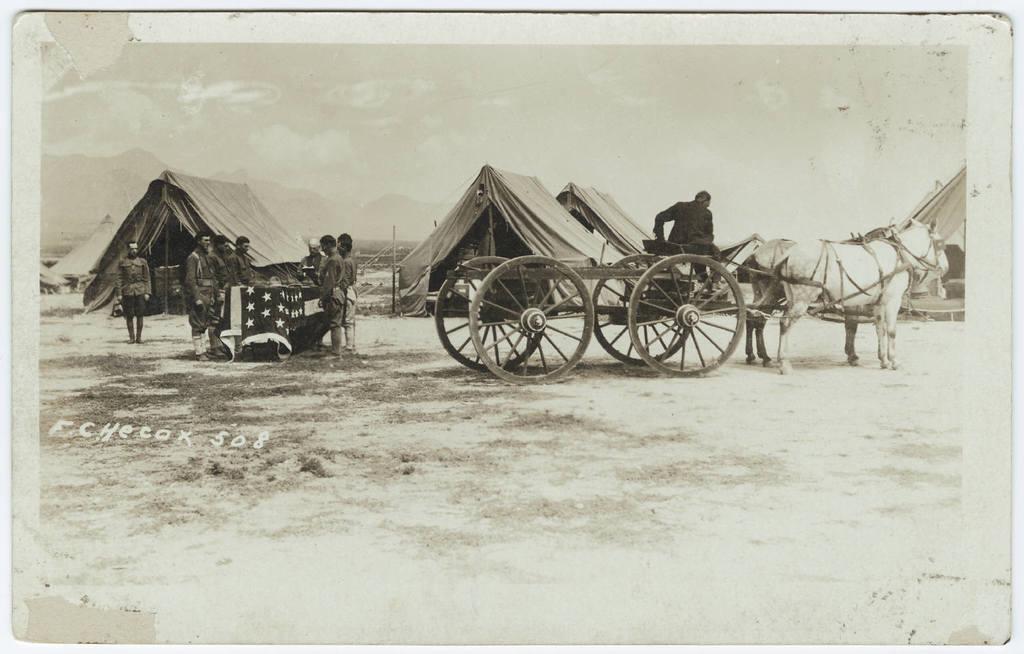How would you summarize this image in a sentence or two? It is an old black and white image. In the left side there are people standing. In the right side it is a horse cart. In the middle there are tents. 